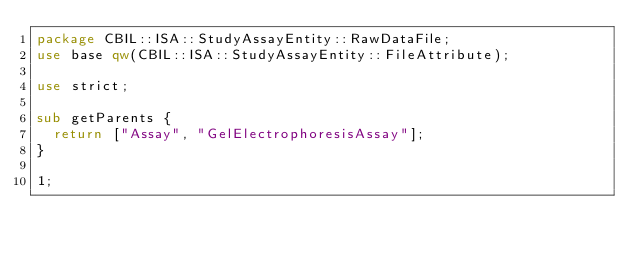Convert code to text. <code><loc_0><loc_0><loc_500><loc_500><_Perl_>package CBIL::ISA::StudyAssayEntity::RawDataFile;
use base qw(CBIL::ISA::StudyAssayEntity::FileAttribute);

use strict;

sub getParents {
  return ["Assay", "GelElectrophoresisAssay"];
}

1;
</code> 